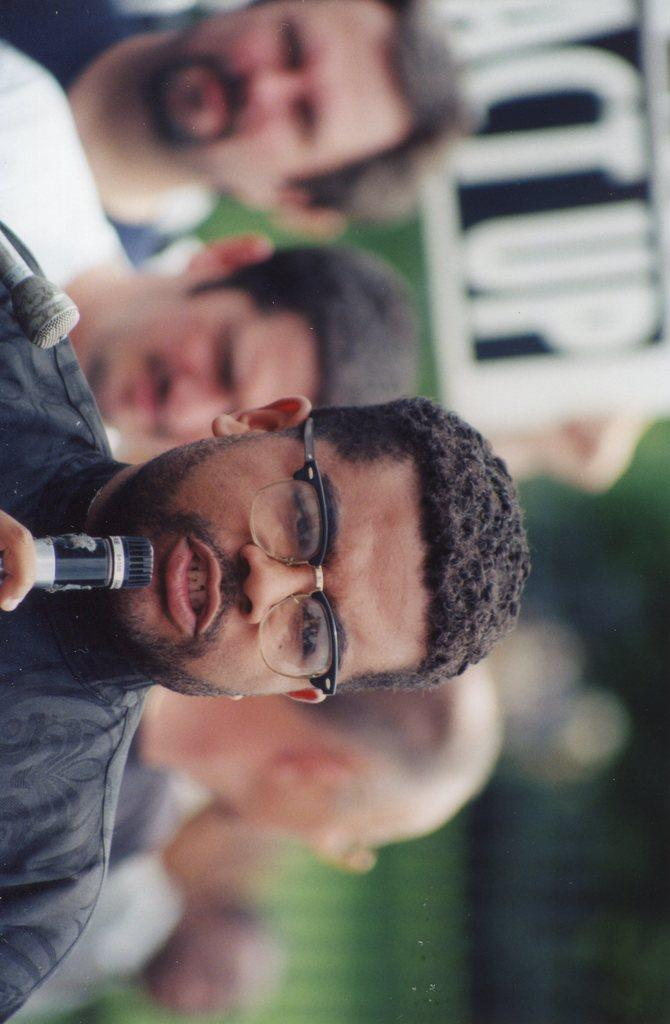Who is the main subject in the image? There is a man in the image. What is the man wearing? The man is wearing glasses. What is the man holding in the image? The man is holding a microphone. What can be seen in the background of the image? There are people and a board visible in the background of the image. What type of chicken is causing a commotion in the image? There is no chicken present in the image, and therefore no commotion caused by a chicken. 